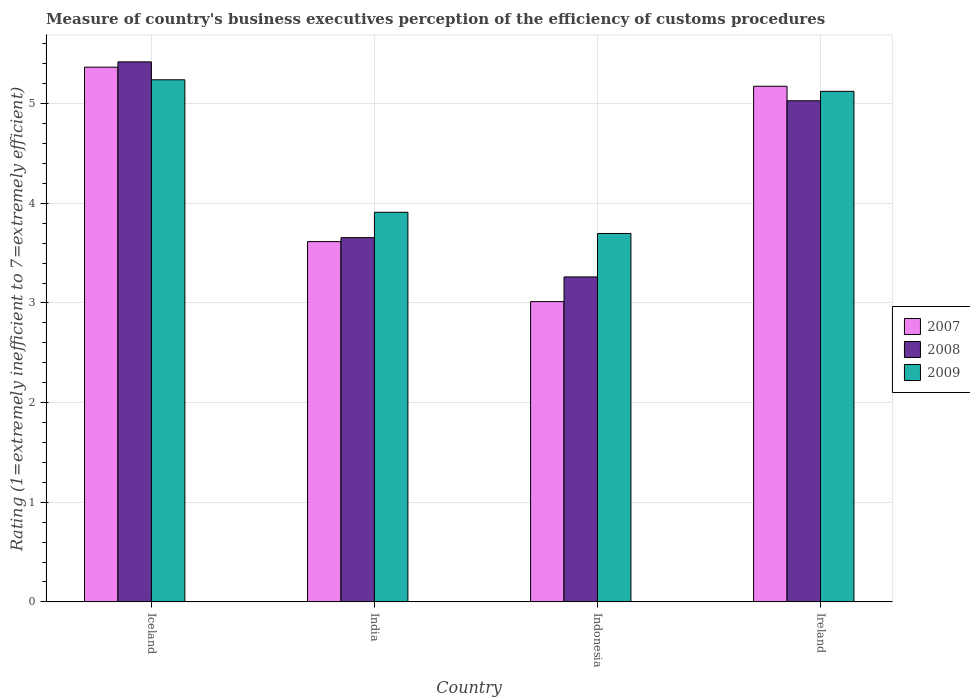How many different coloured bars are there?
Keep it short and to the point. 3. How many groups of bars are there?
Give a very brief answer. 4. Are the number of bars per tick equal to the number of legend labels?
Offer a very short reply. Yes. How many bars are there on the 2nd tick from the right?
Offer a very short reply. 3. What is the label of the 2nd group of bars from the left?
Your response must be concise. India. In how many cases, is the number of bars for a given country not equal to the number of legend labels?
Your answer should be very brief. 0. What is the rating of the efficiency of customs procedure in 2008 in Indonesia?
Provide a short and direct response. 3.26. Across all countries, what is the maximum rating of the efficiency of customs procedure in 2009?
Give a very brief answer. 5.24. Across all countries, what is the minimum rating of the efficiency of customs procedure in 2008?
Make the answer very short. 3.26. In which country was the rating of the efficiency of customs procedure in 2008 maximum?
Offer a terse response. Iceland. What is the total rating of the efficiency of customs procedure in 2007 in the graph?
Give a very brief answer. 17.17. What is the difference between the rating of the efficiency of customs procedure in 2008 in Iceland and that in Indonesia?
Your answer should be compact. 2.16. What is the difference between the rating of the efficiency of customs procedure in 2008 in India and the rating of the efficiency of customs procedure in 2009 in Indonesia?
Offer a very short reply. -0.04. What is the average rating of the efficiency of customs procedure in 2008 per country?
Offer a very short reply. 4.34. What is the difference between the rating of the efficiency of customs procedure of/in 2009 and rating of the efficiency of customs procedure of/in 2008 in Ireland?
Provide a succinct answer. 0.09. In how many countries, is the rating of the efficiency of customs procedure in 2008 greater than 2.4?
Keep it short and to the point. 4. What is the ratio of the rating of the efficiency of customs procedure in 2007 in Indonesia to that in Ireland?
Offer a very short reply. 0.58. Is the difference between the rating of the efficiency of customs procedure in 2009 in Iceland and India greater than the difference between the rating of the efficiency of customs procedure in 2008 in Iceland and India?
Your answer should be very brief. No. What is the difference between the highest and the second highest rating of the efficiency of customs procedure in 2007?
Provide a succinct answer. 1.56. What is the difference between the highest and the lowest rating of the efficiency of customs procedure in 2009?
Provide a succinct answer. 1.54. Is it the case that in every country, the sum of the rating of the efficiency of customs procedure in 2009 and rating of the efficiency of customs procedure in 2008 is greater than the rating of the efficiency of customs procedure in 2007?
Make the answer very short. Yes. How many bars are there?
Your answer should be very brief. 12. What is the difference between two consecutive major ticks on the Y-axis?
Provide a succinct answer. 1. Where does the legend appear in the graph?
Give a very brief answer. Center right. How are the legend labels stacked?
Provide a short and direct response. Vertical. What is the title of the graph?
Your answer should be compact. Measure of country's business executives perception of the efficiency of customs procedures. What is the label or title of the Y-axis?
Your response must be concise. Rating (1=extremely inefficient to 7=extremely efficient). What is the Rating (1=extremely inefficient to 7=extremely efficient) of 2007 in Iceland?
Offer a terse response. 5.37. What is the Rating (1=extremely inefficient to 7=extremely efficient) in 2008 in Iceland?
Provide a succinct answer. 5.42. What is the Rating (1=extremely inefficient to 7=extremely efficient) in 2009 in Iceland?
Offer a terse response. 5.24. What is the Rating (1=extremely inefficient to 7=extremely efficient) in 2007 in India?
Offer a terse response. 3.62. What is the Rating (1=extremely inefficient to 7=extremely efficient) of 2008 in India?
Provide a succinct answer. 3.66. What is the Rating (1=extremely inefficient to 7=extremely efficient) of 2009 in India?
Your answer should be very brief. 3.91. What is the Rating (1=extremely inefficient to 7=extremely efficient) in 2007 in Indonesia?
Ensure brevity in your answer.  3.01. What is the Rating (1=extremely inefficient to 7=extremely efficient) of 2008 in Indonesia?
Ensure brevity in your answer.  3.26. What is the Rating (1=extremely inefficient to 7=extremely efficient) of 2009 in Indonesia?
Give a very brief answer. 3.7. What is the Rating (1=extremely inefficient to 7=extremely efficient) of 2007 in Ireland?
Provide a succinct answer. 5.17. What is the Rating (1=extremely inefficient to 7=extremely efficient) of 2008 in Ireland?
Offer a terse response. 5.03. What is the Rating (1=extremely inefficient to 7=extremely efficient) of 2009 in Ireland?
Provide a short and direct response. 5.12. Across all countries, what is the maximum Rating (1=extremely inefficient to 7=extremely efficient) of 2007?
Your answer should be very brief. 5.37. Across all countries, what is the maximum Rating (1=extremely inefficient to 7=extremely efficient) in 2008?
Your answer should be very brief. 5.42. Across all countries, what is the maximum Rating (1=extremely inefficient to 7=extremely efficient) of 2009?
Keep it short and to the point. 5.24. Across all countries, what is the minimum Rating (1=extremely inefficient to 7=extremely efficient) in 2007?
Your answer should be very brief. 3.01. Across all countries, what is the minimum Rating (1=extremely inefficient to 7=extremely efficient) in 2008?
Provide a succinct answer. 3.26. Across all countries, what is the minimum Rating (1=extremely inefficient to 7=extremely efficient) in 2009?
Your answer should be very brief. 3.7. What is the total Rating (1=extremely inefficient to 7=extremely efficient) of 2007 in the graph?
Offer a terse response. 17.17. What is the total Rating (1=extremely inefficient to 7=extremely efficient) of 2008 in the graph?
Ensure brevity in your answer.  17.37. What is the total Rating (1=extremely inefficient to 7=extremely efficient) in 2009 in the graph?
Provide a short and direct response. 17.97. What is the difference between the Rating (1=extremely inefficient to 7=extremely efficient) in 2007 in Iceland and that in India?
Your answer should be very brief. 1.75. What is the difference between the Rating (1=extremely inefficient to 7=extremely efficient) in 2008 in Iceland and that in India?
Offer a very short reply. 1.76. What is the difference between the Rating (1=extremely inefficient to 7=extremely efficient) of 2009 in Iceland and that in India?
Provide a short and direct response. 1.33. What is the difference between the Rating (1=extremely inefficient to 7=extremely efficient) in 2007 in Iceland and that in Indonesia?
Provide a short and direct response. 2.35. What is the difference between the Rating (1=extremely inefficient to 7=extremely efficient) in 2008 in Iceland and that in Indonesia?
Offer a terse response. 2.16. What is the difference between the Rating (1=extremely inefficient to 7=extremely efficient) of 2009 in Iceland and that in Indonesia?
Make the answer very short. 1.54. What is the difference between the Rating (1=extremely inefficient to 7=extremely efficient) in 2007 in Iceland and that in Ireland?
Your answer should be very brief. 0.19. What is the difference between the Rating (1=extremely inefficient to 7=extremely efficient) of 2008 in Iceland and that in Ireland?
Keep it short and to the point. 0.39. What is the difference between the Rating (1=extremely inefficient to 7=extremely efficient) in 2009 in Iceland and that in Ireland?
Provide a short and direct response. 0.12. What is the difference between the Rating (1=extremely inefficient to 7=extremely efficient) of 2007 in India and that in Indonesia?
Your answer should be very brief. 0.6. What is the difference between the Rating (1=extremely inefficient to 7=extremely efficient) of 2008 in India and that in Indonesia?
Give a very brief answer. 0.39. What is the difference between the Rating (1=extremely inefficient to 7=extremely efficient) in 2009 in India and that in Indonesia?
Offer a very short reply. 0.21. What is the difference between the Rating (1=extremely inefficient to 7=extremely efficient) of 2007 in India and that in Ireland?
Give a very brief answer. -1.56. What is the difference between the Rating (1=extremely inefficient to 7=extremely efficient) of 2008 in India and that in Ireland?
Provide a succinct answer. -1.37. What is the difference between the Rating (1=extremely inefficient to 7=extremely efficient) of 2009 in India and that in Ireland?
Provide a short and direct response. -1.21. What is the difference between the Rating (1=extremely inefficient to 7=extremely efficient) of 2007 in Indonesia and that in Ireland?
Keep it short and to the point. -2.16. What is the difference between the Rating (1=extremely inefficient to 7=extremely efficient) of 2008 in Indonesia and that in Ireland?
Your response must be concise. -1.77. What is the difference between the Rating (1=extremely inefficient to 7=extremely efficient) of 2009 in Indonesia and that in Ireland?
Your response must be concise. -1.43. What is the difference between the Rating (1=extremely inefficient to 7=extremely efficient) of 2007 in Iceland and the Rating (1=extremely inefficient to 7=extremely efficient) of 2008 in India?
Your answer should be very brief. 1.71. What is the difference between the Rating (1=extremely inefficient to 7=extremely efficient) in 2007 in Iceland and the Rating (1=extremely inefficient to 7=extremely efficient) in 2009 in India?
Ensure brevity in your answer.  1.46. What is the difference between the Rating (1=extremely inefficient to 7=extremely efficient) in 2008 in Iceland and the Rating (1=extremely inefficient to 7=extremely efficient) in 2009 in India?
Your answer should be compact. 1.51. What is the difference between the Rating (1=extremely inefficient to 7=extremely efficient) of 2007 in Iceland and the Rating (1=extremely inefficient to 7=extremely efficient) of 2008 in Indonesia?
Offer a terse response. 2.11. What is the difference between the Rating (1=extremely inefficient to 7=extremely efficient) in 2007 in Iceland and the Rating (1=extremely inefficient to 7=extremely efficient) in 2009 in Indonesia?
Keep it short and to the point. 1.67. What is the difference between the Rating (1=extremely inefficient to 7=extremely efficient) in 2008 in Iceland and the Rating (1=extremely inefficient to 7=extremely efficient) in 2009 in Indonesia?
Ensure brevity in your answer.  1.72. What is the difference between the Rating (1=extremely inefficient to 7=extremely efficient) of 2007 in Iceland and the Rating (1=extremely inefficient to 7=extremely efficient) of 2008 in Ireland?
Your answer should be compact. 0.34. What is the difference between the Rating (1=extremely inefficient to 7=extremely efficient) of 2007 in Iceland and the Rating (1=extremely inefficient to 7=extremely efficient) of 2009 in Ireland?
Ensure brevity in your answer.  0.24. What is the difference between the Rating (1=extremely inefficient to 7=extremely efficient) in 2008 in Iceland and the Rating (1=extremely inefficient to 7=extremely efficient) in 2009 in Ireland?
Give a very brief answer. 0.3. What is the difference between the Rating (1=extremely inefficient to 7=extremely efficient) of 2007 in India and the Rating (1=extremely inefficient to 7=extremely efficient) of 2008 in Indonesia?
Your answer should be compact. 0.35. What is the difference between the Rating (1=extremely inefficient to 7=extremely efficient) of 2007 in India and the Rating (1=extremely inefficient to 7=extremely efficient) of 2009 in Indonesia?
Ensure brevity in your answer.  -0.08. What is the difference between the Rating (1=extremely inefficient to 7=extremely efficient) in 2008 in India and the Rating (1=extremely inefficient to 7=extremely efficient) in 2009 in Indonesia?
Make the answer very short. -0.04. What is the difference between the Rating (1=extremely inefficient to 7=extremely efficient) in 2007 in India and the Rating (1=extremely inefficient to 7=extremely efficient) in 2008 in Ireland?
Provide a short and direct response. -1.41. What is the difference between the Rating (1=extremely inefficient to 7=extremely efficient) of 2007 in India and the Rating (1=extremely inefficient to 7=extremely efficient) of 2009 in Ireland?
Make the answer very short. -1.51. What is the difference between the Rating (1=extremely inefficient to 7=extremely efficient) in 2008 in India and the Rating (1=extremely inefficient to 7=extremely efficient) in 2009 in Ireland?
Keep it short and to the point. -1.47. What is the difference between the Rating (1=extremely inefficient to 7=extremely efficient) in 2007 in Indonesia and the Rating (1=extremely inefficient to 7=extremely efficient) in 2008 in Ireland?
Make the answer very short. -2.02. What is the difference between the Rating (1=extremely inefficient to 7=extremely efficient) in 2007 in Indonesia and the Rating (1=extremely inefficient to 7=extremely efficient) in 2009 in Ireland?
Offer a very short reply. -2.11. What is the difference between the Rating (1=extremely inefficient to 7=extremely efficient) of 2008 in Indonesia and the Rating (1=extremely inefficient to 7=extremely efficient) of 2009 in Ireland?
Ensure brevity in your answer.  -1.86. What is the average Rating (1=extremely inefficient to 7=extremely efficient) of 2007 per country?
Your answer should be compact. 4.29. What is the average Rating (1=extremely inefficient to 7=extremely efficient) of 2008 per country?
Provide a short and direct response. 4.34. What is the average Rating (1=extremely inefficient to 7=extremely efficient) of 2009 per country?
Give a very brief answer. 4.49. What is the difference between the Rating (1=extremely inefficient to 7=extremely efficient) in 2007 and Rating (1=extremely inefficient to 7=extremely efficient) in 2008 in Iceland?
Keep it short and to the point. -0.05. What is the difference between the Rating (1=extremely inefficient to 7=extremely efficient) in 2007 and Rating (1=extremely inefficient to 7=extremely efficient) in 2009 in Iceland?
Make the answer very short. 0.13. What is the difference between the Rating (1=extremely inefficient to 7=extremely efficient) of 2008 and Rating (1=extremely inefficient to 7=extremely efficient) of 2009 in Iceland?
Keep it short and to the point. 0.18. What is the difference between the Rating (1=extremely inefficient to 7=extremely efficient) in 2007 and Rating (1=extremely inefficient to 7=extremely efficient) in 2008 in India?
Keep it short and to the point. -0.04. What is the difference between the Rating (1=extremely inefficient to 7=extremely efficient) in 2007 and Rating (1=extremely inefficient to 7=extremely efficient) in 2009 in India?
Give a very brief answer. -0.29. What is the difference between the Rating (1=extremely inefficient to 7=extremely efficient) in 2008 and Rating (1=extremely inefficient to 7=extremely efficient) in 2009 in India?
Offer a terse response. -0.25. What is the difference between the Rating (1=extremely inefficient to 7=extremely efficient) of 2007 and Rating (1=extremely inefficient to 7=extremely efficient) of 2008 in Indonesia?
Keep it short and to the point. -0.25. What is the difference between the Rating (1=extremely inefficient to 7=extremely efficient) of 2007 and Rating (1=extremely inefficient to 7=extremely efficient) of 2009 in Indonesia?
Ensure brevity in your answer.  -0.68. What is the difference between the Rating (1=extremely inefficient to 7=extremely efficient) of 2008 and Rating (1=extremely inefficient to 7=extremely efficient) of 2009 in Indonesia?
Offer a very short reply. -0.44. What is the difference between the Rating (1=extremely inefficient to 7=extremely efficient) of 2007 and Rating (1=extremely inefficient to 7=extremely efficient) of 2008 in Ireland?
Offer a very short reply. 0.15. What is the difference between the Rating (1=extremely inefficient to 7=extremely efficient) in 2007 and Rating (1=extremely inefficient to 7=extremely efficient) in 2009 in Ireland?
Offer a very short reply. 0.05. What is the difference between the Rating (1=extremely inefficient to 7=extremely efficient) in 2008 and Rating (1=extremely inefficient to 7=extremely efficient) in 2009 in Ireland?
Keep it short and to the point. -0.09. What is the ratio of the Rating (1=extremely inefficient to 7=extremely efficient) in 2007 in Iceland to that in India?
Provide a succinct answer. 1.48. What is the ratio of the Rating (1=extremely inefficient to 7=extremely efficient) of 2008 in Iceland to that in India?
Your response must be concise. 1.48. What is the ratio of the Rating (1=extremely inefficient to 7=extremely efficient) in 2009 in Iceland to that in India?
Your answer should be very brief. 1.34. What is the ratio of the Rating (1=extremely inefficient to 7=extremely efficient) of 2007 in Iceland to that in Indonesia?
Provide a succinct answer. 1.78. What is the ratio of the Rating (1=extremely inefficient to 7=extremely efficient) in 2008 in Iceland to that in Indonesia?
Offer a very short reply. 1.66. What is the ratio of the Rating (1=extremely inefficient to 7=extremely efficient) in 2009 in Iceland to that in Indonesia?
Your answer should be compact. 1.42. What is the ratio of the Rating (1=extremely inefficient to 7=extremely efficient) in 2007 in Iceland to that in Ireland?
Keep it short and to the point. 1.04. What is the ratio of the Rating (1=extremely inefficient to 7=extremely efficient) of 2008 in Iceland to that in Ireland?
Provide a succinct answer. 1.08. What is the ratio of the Rating (1=extremely inefficient to 7=extremely efficient) of 2009 in Iceland to that in Ireland?
Keep it short and to the point. 1.02. What is the ratio of the Rating (1=extremely inefficient to 7=extremely efficient) of 2007 in India to that in Indonesia?
Offer a very short reply. 1.2. What is the ratio of the Rating (1=extremely inefficient to 7=extremely efficient) of 2008 in India to that in Indonesia?
Give a very brief answer. 1.12. What is the ratio of the Rating (1=extremely inefficient to 7=extremely efficient) in 2009 in India to that in Indonesia?
Your answer should be very brief. 1.06. What is the ratio of the Rating (1=extremely inefficient to 7=extremely efficient) in 2007 in India to that in Ireland?
Keep it short and to the point. 0.7. What is the ratio of the Rating (1=extremely inefficient to 7=extremely efficient) of 2008 in India to that in Ireland?
Offer a very short reply. 0.73. What is the ratio of the Rating (1=extremely inefficient to 7=extremely efficient) in 2009 in India to that in Ireland?
Provide a short and direct response. 0.76. What is the ratio of the Rating (1=extremely inefficient to 7=extremely efficient) in 2007 in Indonesia to that in Ireland?
Your response must be concise. 0.58. What is the ratio of the Rating (1=extremely inefficient to 7=extremely efficient) in 2008 in Indonesia to that in Ireland?
Make the answer very short. 0.65. What is the ratio of the Rating (1=extremely inefficient to 7=extremely efficient) in 2009 in Indonesia to that in Ireland?
Ensure brevity in your answer.  0.72. What is the difference between the highest and the second highest Rating (1=extremely inefficient to 7=extremely efficient) in 2007?
Your response must be concise. 0.19. What is the difference between the highest and the second highest Rating (1=extremely inefficient to 7=extremely efficient) of 2008?
Offer a very short reply. 0.39. What is the difference between the highest and the second highest Rating (1=extremely inefficient to 7=extremely efficient) of 2009?
Ensure brevity in your answer.  0.12. What is the difference between the highest and the lowest Rating (1=extremely inefficient to 7=extremely efficient) in 2007?
Offer a terse response. 2.35. What is the difference between the highest and the lowest Rating (1=extremely inefficient to 7=extremely efficient) of 2008?
Your answer should be very brief. 2.16. What is the difference between the highest and the lowest Rating (1=extremely inefficient to 7=extremely efficient) of 2009?
Ensure brevity in your answer.  1.54. 